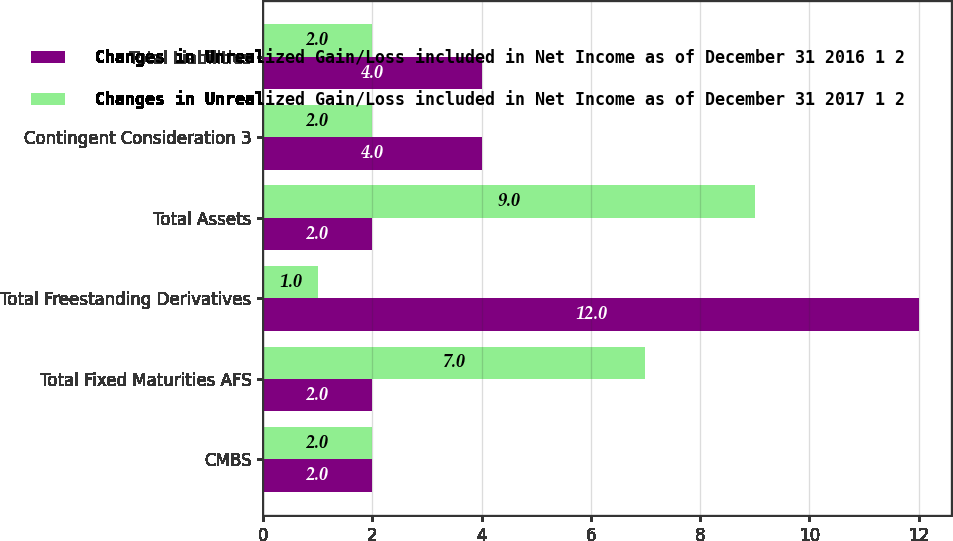Convert chart to OTSL. <chart><loc_0><loc_0><loc_500><loc_500><stacked_bar_chart><ecel><fcel>CMBS<fcel>Total Fixed Maturities AFS<fcel>Total Freestanding Derivatives<fcel>Total Assets<fcel>Contingent Consideration 3<fcel>Total Liabilities<nl><fcel>Changes in Unrealized Gain/Loss included in Net Income as of December 31 2016 1 2<fcel>2<fcel>2<fcel>12<fcel>2<fcel>4<fcel>4<nl><fcel>Changes in Unrealized Gain/Loss included in Net Income as of December 31 2017 1 2<fcel>2<fcel>7<fcel>1<fcel>9<fcel>2<fcel>2<nl></chart> 